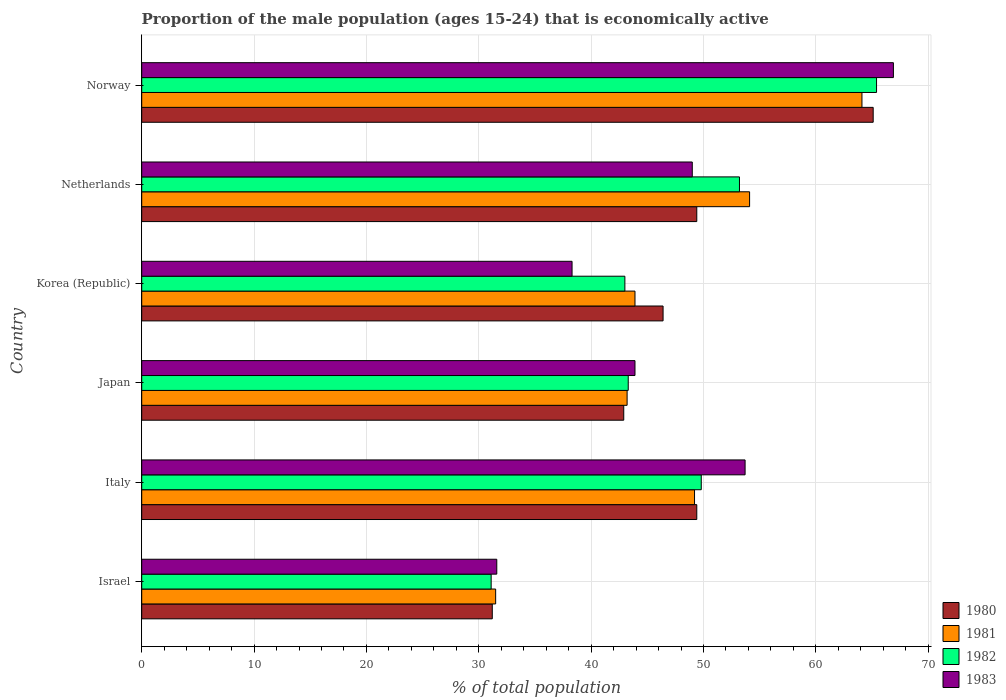How many groups of bars are there?
Your response must be concise. 6. Are the number of bars per tick equal to the number of legend labels?
Give a very brief answer. Yes. How many bars are there on the 5th tick from the top?
Your response must be concise. 4. How many bars are there on the 4th tick from the bottom?
Offer a very short reply. 4. What is the proportion of the male population that is economically active in 1982 in Netherlands?
Ensure brevity in your answer.  53.2. Across all countries, what is the maximum proportion of the male population that is economically active in 1980?
Provide a short and direct response. 65.1. Across all countries, what is the minimum proportion of the male population that is economically active in 1981?
Offer a terse response. 31.5. In which country was the proportion of the male population that is economically active in 1981 maximum?
Provide a short and direct response. Norway. What is the total proportion of the male population that is economically active in 1983 in the graph?
Give a very brief answer. 283.4. What is the difference between the proportion of the male population that is economically active in 1982 in Israel and that in Korea (Republic)?
Give a very brief answer. -11.9. What is the difference between the proportion of the male population that is economically active in 1981 in Japan and the proportion of the male population that is economically active in 1982 in Italy?
Offer a terse response. -6.6. What is the average proportion of the male population that is economically active in 1983 per country?
Give a very brief answer. 47.23. What is the difference between the proportion of the male population that is economically active in 1980 and proportion of the male population that is economically active in 1983 in Japan?
Your answer should be very brief. -1. In how many countries, is the proportion of the male population that is economically active in 1981 greater than 44 %?
Offer a terse response. 3. What is the ratio of the proportion of the male population that is economically active in 1981 in Italy to that in Norway?
Give a very brief answer. 0.77. Is the proportion of the male population that is economically active in 1982 in Japan less than that in Norway?
Provide a succinct answer. Yes. What is the difference between the highest and the second highest proportion of the male population that is economically active in 1981?
Your answer should be very brief. 10. What is the difference between the highest and the lowest proportion of the male population that is economically active in 1982?
Make the answer very short. 34.3. Is it the case that in every country, the sum of the proportion of the male population that is economically active in 1980 and proportion of the male population that is economically active in 1982 is greater than the proportion of the male population that is economically active in 1983?
Provide a short and direct response. Yes. How many countries are there in the graph?
Your answer should be compact. 6. Does the graph contain grids?
Provide a succinct answer. Yes. How many legend labels are there?
Keep it short and to the point. 4. How are the legend labels stacked?
Your answer should be compact. Vertical. What is the title of the graph?
Make the answer very short. Proportion of the male population (ages 15-24) that is economically active. What is the label or title of the X-axis?
Provide a short and direct response. % of total population. What is the % of total population of 1980 in Israel?
Offer a very short reply. 31.2. What is the % of total population in 1981 in Israel?
Provide a succinct answer. 31.5. What is the % of total population in 1982 in Israel?
Keep it short and to the point. 31.1. What is the % of total population in 1983 in Israel?
Keep it short and to the point. 31.6. What is the % of total population of 1980 in Italy?
Provide a succinct answer. 49.4. What is the % of total population in 1981 in Italy?
Your answer should be compact. 49.2. What is the % of total population in 1982 in Italy?
Your answer should be very brief. 49.8. What is the % of total population of 1983 in Italy?
Provide a short and direct response. 53.7. What is the % of total population in 1980 in Japan?
Your answer should be very brief. 42.9. What is the % of total population in 1981 in Japan?
Provide a succinct answer. 43.2. What is the % of total population in 1982 in Japan?
Your answer should be very brief. 43.3. What is the % of total population in 1983 in Japan?
Keep it short and to the point. 43.9. What is the % of total population in 1980 in Korea (Republic)?
Offer a very short reply. 46.4. What is the % of total population in 1981 in Korea (Republic)?
Offer a very short reply. 43.9. What is the % of total population in 1983 in Korea (Republic)?
Make the answer very short. 38.3. What is the % of total population of 1980 in Netherlands?
Your answer should be very brief. 49.4. What is the % of total population in 1981 in Netherlands?
Give a very brief answer. 54.1. What is the % of total population in 1982 in Netherlands?
Give a very brief answer. 53.2. What is the % of total population in 1983 in Netherlands?
Keep it short and to the point. 49. What is the % of total population of 1980 in Norway?
Your response must be concise. 65.1. What is the % of total population in 1981 in Norway?
Give a very brief answer. 64.1. What is the % of total population in 1982 in Norway?
Your answer should be very brief. 65.4. What is the % of total population in 1983 in Norway?
Offer a very short reply. 66.9. Across all countries, what is the maximum % of total population of 1980?
Offer a terse response. 65.1. Across all countries, what is the maximum % of total population in 1981?
Ensure brevity in your answer.  64.1. Across all countries, what is the maximum % of total population of 1982?
Ensure brevity in your answer.  65.4. Across all countries, what is the maximum % of total population of 1983?
Make the answer very short. 66.9. Across all countries, what is the minimum % of total population in 1980?
Keep it short and to the point. 31.2. Across all countries, what is the minimum % of total population of 1981?
Your response must be concise. 31.5. Across all countries, what is the minimum % of total population of 1982?
Offer a terse response. 31.1. Across all countries, what is the minimum % of total population in 1983?
Provide a short and direct response. 31.6. What is the total % of total population of 1980 in the graph?
Your answer should be very brief. 284.4. What is the total % of total population in 1981 in the graph?
Your response must be concise. 286. What is the total % of total population of 1982 in the graph?
Your answer should be compact. 285.8. What is the total % of total population in 1983 in the graph?
Your response must be concise. 283.4. What is the difference between the % of total population in 1980 in Israel and that in Italy?
Offer a terse response. -18.2. What is the difference between the % of total population of 1981 in Israel and that in Italy?
Your response must be concise. -17.7. What is the difference between the % of total population in 1982 in Israel and that in Italy?
Your answer should be very brief. -18.7. What is the difference between the % of total population of 1983 in Israel and that in Italy?
Your response must be concise. -22.1. What is the difference between the % of total population of 1981 in Israel and that in Japan?
Offer a terse response. -11.7. What is the difference between the % of total population in 1983 in Israel and that in Japan?
Give a very brief answer. -12.3. What is the difference between the % of total population in 1980 in Israel and that in Korea (Republic)?
Your response must be concise. -15.2. What is the difference between the % of total population of 1981 in Israel and that in Korea (Republic)?
Your response must be concise. -12.4. What is the difference between the % of total population in 1982 in Israel and that in Korea (Republic)?
Your answer should be very brief. -11.9. What is the difference between the % of total population of 1983 in Israel and that in Korea (Republic)?
Ensure brevity in your answer.  -6.7. What is the difference between the % of total population in 1980 in Israel and that in Netherlands?
Offer a terse response. -18.2. What is the difference between the % of total population in 1981 in Israel and that in Netherlands?
Provide a short and direct response. -22.6. What is the difference between the % of total population of 1982 in Israel and that in Netherlands?
Offer a very short reply. -22.1. What is the difference between the % of total population of 1983 in Israel and that in Netherlands?
Ensure brevity in your answer.  -17.4. What is the difference between the % of total population in 1980 in Israel and that in Norway?
Offer a terse response. -33.9. What is the difference between the % of total population in 1981 in Israel and that in Norway?
Ensure brevity in your answer.  -32.6. What is the difference between the % of total population in 1982 in Israel and that in Norway?
Offer a terse response. -34.3. What is the difference between the % of total population of 1983 in Israel and that in Norway?
Give a very brief answer. -35.3. What is the difference between the % of total population of 1982 in Italy and that in Japan?
Give a very brief answer. 6.5. What is the difference between the % of total population of 1983 in Italy and that in Japan?
Keep it short and to the point. 9.8. What is the difference between the % of total population in 1981 in Italy and that in Korea (Republic)?
Your response must be concise. 5.3. What is the difference between the % of total population in 1980 in Italy and that in Netherlands?
Your answer should be compact. 0. What is the difference between the % of total population in 1982 in Italy and that in Netherlands?
Give a very brief answer. -3.4. What is the difference between the % of total population in 1980 in Italy and that in Norway?
Provide a succinct answer. -15.7. What is the difference between the % of total population in 1981 in Italy and that in Norway?
Give a very brief answer. -14.9. What is the difference between the % of total population in 1982 in Italy and that in Norway?
Offer a very short reply. -15.6. What is the difference between the % of total population in 1981 in Japan and that in Korea (Republic)?
Your answer should be compact. -0.7. What is the difference between the % of total population in 1982 in Japan and that in Korea (Republic)?
Offer a very short reply. 0.3. What is the difference between the % of total population in 1980 in Japan and that in Netherlands?
Provide a succinct answer. -6.5. What is the difference between the % of total population of 1982 in Japan and that in Netherlands?
Offer a very short reply. -9.9. What is the difference between the % of total population in 1983 in Japan and that in Netherlands?
Make the answer very short. -5.1. What is the difference between the % of total population in 1980 in Japan and that in Norway?
Provide a short and direct response. -22.2. What is the difference between the % of total population in 1981 in Japan and that in Norway?
Make the answer very short. -20.9. What is the difference between the % of total population in 1982 in Japan and that in Norway?
Give a very brief answer. -22.1. What is the difference between the % of total population in 1983 in Japan and that in Norway?
Keep it short and to the point. -23. What is the difference between the % of total population of 1980 in Korea (Republic) and that in Netherlands?
Keep it short and to the point. -3. What is the difference between the % of total population in 1982 in Korea (Republic) and that in Netherlands?
Provide a short and direct response. -10.2. What is the difference between the % of total population of 1983 in Korea (Republic) and that in Netherlands?
Offer a very short reply. -10.7. What is the difference between the % of total population in 1980 in Korea (Republic) and that in Norway?
Offer a very short reply. -18.7. What is the difference between the % of total population in 1981 in Korea (Republic) and that in Norway?
Offer a terse response. -20.2. What is the difference between the % of total population in 1982 in Korea (Republic) and that in Norway?
Offer a very short reply. -22.4. What is the difference between the % of total population of 1983 in Korea (Republic) and that in Norway?
Your answer should be very brief. -28.6. What is the difference between the % of total population of 1980 in Netherlands and that in Norway?
Provide a short and direct response. -15.7. What is the difference between the % of total population of 1981 in Netherlands and that in Norway?
Your answer should be very brief. -10. What is the difference between the % of total population in 1982 in Netherlands and that in Norway?
Keep it short and to the point. -12.2. What is the difference between the % of total population in 1983 in Netherlands and that in Norway?
Your answer should be very brief. -17.9. What is the difference between the % of total population of 1980 in Israel and the % of total population of 1982 in Italy?
Provide a short and direct response. -18.6. What is the difference between the % of total population in 1980 in Israel and the % of total population in 1983 in Italy?
Your response must be concise. -22.5. What is the difference between the % of total population in 1981 in Israel and the % of total population in 1982 in Italy?
Offer a very short reply. -18.3. What is the difference between the % of total population of 1981 in Israel and the % of total population of 1983 in Italy?
Your answer should be very brief. -22.2. What is the difference between the % of total population of 1982 in Israel and the % of total population of 1983 in Italy?
Offer a very short reply. -22.6. What is the difference between the % of total population in 1980 in Israel and the % of total population in 1981 in Japan?
Ensure brevity in your answer.  -12. What is the difference between the % of total population of 1980 in Israel and the % of total population of 1982 in Japan?
Provide a succinct answer. -12.1. What is the difference between the % of total population of 1981 in Israel and the % of total population of 1982 in Japan?
Offer a very short reply. -11.8. What is the difference between the % of total population of 1981 in Israel and the % of total population of 1983 in Japan?
Keep it short and to the point. -12.4. What is the difference between the % of total population of 1981 in Israel and the % of total population of 1982 in Korea (Republic)?
Offer a very short reply. -11.5. What is the difference between the % of total population of 1980 in Israel and the % of total population of 1981 in Netherlands?
Offer a terse response. -22.9. What is the difference between the % of total population in 1980 in Israel and the % of total population in 1982 in Netherlands?
Your answer should be very brief. -22. What is the difference between the % of total population of 1980 in Israel and the % of total population of 1983 in Netherlands?
Give a very brief answer. -17.8. What is the difference between the % of total population in 1981 in Israel and the % of total population in 1982 in Netherlands?
Offer a very short reply. -21.7. What is the difference between the % of total population of 1981 in Israel and the % of total population of 1983 in Netherlands?
Give a very brief answer. -17.5. What is the difference between the % of total population in 1982 in Israel and the % of total population in 1983 in Netherlands?
Provide a short and direct response. -17.9. What is the difference between the % of total population in 1980 in Israel and the % of total population in 1981 in Norway?
Provide a short and direct response. -32.9. What is the difference between the % of total population in 1980 in Israel and the % of total population in 1982 in Norway?
Give a very brief answer. -34.2. What is the difference between the % of total population of 1980 in Israel and the % of total population of 1983 in Norway?
Give a very brief answer. -35.7. What is the difference between the % of total population in 1981 in Israel and the % of total population in 1982 in Norway?
Your answer should be very brief. -33.9. What is the difference between the % of total population in 1981 in Israel and the % of total population in 1983 in Norway?
Your answer should be very brief. -35.4. What is the difference between the % of total population of 1982 in Israel and the % of total population of 1983 in Norway?
Offer a terse response. -35.8. What is the difference between the % of total population in 1980 in Italy and the % of total population in 1981 in Japan?
Offer a very short reply. 6.2. What is the difference between the % of total population in 1980 in Italy and the % of total population in 1982 in Japan?
Your answer should be very brief. 6.1. What is the difference between the % of total population of 1980 in Italy and the % of total population of 1983 in Japan?
Make the answer very short. 5.5. What is the difference between the % of total population of 1981 in Italy and the % of total population of 1982 in Japan?
Provide a succinct answer. 5.9. What is the difference between the % of total population in 1981 in Italy and the % of total population in 1983 in Japan?
Give a very brief answer. 5.3. What is the difference between the % of total population of 1980 in Italy and the % of total population of 1982 in Korea (Republic)?
Ensure brevity in your answer.  6.4. What is the difference between the % of total population in 1980 in Italy and the % of total population in 1983 in Korea (Republic)?
Ensure brevity in your answer.  11.1. What is the difference between the % of total population in 1981 in Italy and the % of total population in 1982 in Korea (Republic)?
Ensure brevity in your answer.  6.2. What is the difference between the % of total population of 1982 in Italy and the % of total population of 1983 in Korea (Republic)?
Keep it short and to the point. 11.5. What is the difference between the % of total population of 1980 in Italy and the % of total population of 1981 in Netherlands?
Offer a very short reply. -4.7. What is the difference between the % of total population in 1980 in Italy and the % of total population in 1982 in Netherlands?
Provide a succinct answer. -3.8. What is the difference between the % of total population in 1981 in Italy and the % of total population in 1982 in Netherlands?
Provide a succinct answer. -4. What is the difference between the % of total population of 1981 in Italy and the % of total population of 1983 in Netherlands?
Your answer should be compact. 0.2. What is the difference between the % of total population in 1980 in Italy and the % of total population in 1981 in Norway?
Your response must be concise. -14.7. What is the difference between the % of total population in 1980 in Italy and the % of total population in 1982 in Norway?
Ensure brevity in your answer.  -16. What is the difference between the % of total population of 1980 in Italy and the % of total population of 1983 in Norway?
Offer a very short reply. -17.5. What is the difference between the % of total population of 1981 in Italy and the % of total population of 1982 in Norway?
Provide a short and direct response. -16.2. What is the difference between the % of total population of 1981 in Italy and the % of total population of 1983 in Norway?
Your answer should be compact. -17.7. What is the difference between the % of total population in 1982 in Italy and the % of total population in 1983 in Norway?
Keep it short and to the point. -17.1. What is the difference between the % of total population in 1980 in Japan and the % of total population in 1982 in Korea (Republic)?
Your answer should be very brief. -0.1. What is the difference between the % of total population in 1980 in Japan and the % of total population in 1981 in Netherlands?
Keep it short and to the point. -11.2. What is the difference between the % of total population in 1980 in Japan and the % of total population in 1983 in Netherlands?
Your answer should be very brief. -6.1. What is the difference between the % of total population of 1981 in Japan and the % of total population of 1982 in Netherlands?
Give a very brief answer. -10. What is the difference between the % of total population of 1982 in Japan and the % of total population of 1983 in Netherlands?
Offer a terse response. -5.7. What is the difference between the % of total population in 1980 in Japan and the % of total population in 1981 in Norway?
Keep it short and to the point. -21.2. What is the difference between the % of total population in 1980 in Japan and the % of total population in 1982 in Norway?
Your answer should be compact. -22.5. What is the difference between the % of total population of 1981 in Japan and the % of total population of 1982 in Norway?
Give a very brief answer. -22.2. What is the difference between the % of total population in 1981 in Japan and the % of total population in 1983 in Norway?
Provide a short and direct response. -23.7. What is the difference between the % of total population in 1982 in Japan and the % of total population in 1983 in Norway?
Your answer should be compact. -23.6. What is the difference between the % of total population of 1980 in Korea (Republic) and the % of total population of 1981 in Netherlands?
Your answer should be very brief. -7.7. What is the difference between the % of total population in 1980 in Korea (Republic) and the % of total population in 1983 in Netherlands?
Offer a terse response. -2.6. What is the difference between the % of total population in 1981 in Korea (Republic) and the % of total population in 1982 in Netherlands?
Give a very brief answer. -9.3. What is the difference between the % of total population of 1981 in Korea (Republic) and the % of total population of 1983 in Netherlands?
Offer a very short reply. -5.1. What is the difference between the % of total population in 1980 in Korea (Republic) and the % of total population in 1981 in Norway?
Offer a very short reply. -17.7. What is the difference between the % of total population of 1980 in Korea (Republic) and the % of total population of 1982 in Norway?
Keep it short and to the point. -19. What is the difference between the % of total population of 1980 in Korea (Republic) and the % of total population of 1983 in Norway?
Your response must be concise. -20.5. What is the difference between the % of total population of 1981 in Korea (Republic) and the % of total population of 1982 in Norway?
Offer a very short reply. -21.5. What is the difference between the % of total population in 1981 in Korea (Republic) and the % of total population in 1983 in Norway?
Your answer should be compact. -23. What is the difference between the % of total population in 1982 in Korea (Republic) and the % of total population in 1983 in Norway?
Keep it short and to the point. -23.9. What is the difference between the % of total population of 1980 in Netherlands and the % of total population of 1981 in Norway?
Ensure brevity in your answer.  -14.7. What is the difference between the % of total population in 1980 in Netherlands and the % of total population in 1983 in Norway?
Your answer should be very brief. -17.5. What is the difference between the % of total population of 1981 in Netherlands and the % of total population of 1983 in Norway?
Your answer should be very brief. -12.8. What is the difference between the % of total population of 1982 in Netherlands and the % of total population of 1983 in Norway?
Offer a very short reply. -13.7. What is the average % of total population of 1980 per country?
Your response must be concise. 47.4. What is the average % of total population of 1981 per country?
Your response must be concise. 47.67. What is the average % of total population in 1982 per country?
Provide a short and direct response. 47.63. What is the average % of total population of 1983 per country?
Give a very brief answer. 47.23. What is the difference between the % of total population of 1980 and % of total population of 1983 in Israel?
Provide a short and direct response. -0.4. What is the difference between the % of total population in 1981 and % of total population in 1983 in Israel?
Offer a terse response. -0.1. What is the difference between the % of total population in 1982 and % of total population in 1983 in Israel?
Offer a terse response. -0.5. What is the difference between the % of total population in 1980 and % of total population in 1981 in Italy?
Provide a succinct answer. 0.2. What is the difference between the % of total population in 1980 and % of total population in 1982 in Italy?
Offer a very short reply. -0.4. What is the difference between the % of total population of 1981 and % of total population of 1982 in Italy?
Keep it short and to the point. -0.6. What is the difference between the % of total population of 1980 and % of total population of 1981 in Japan?
Make the answer very short. -0.3. What is the difference between the % of total population in 1980 and % of total population in 1982 in Japan?
Make the answer very short. -0.4. What is the difference between the % of total population in 1980 and % of total population in 1983 in Japan?
Make the answer very short. -1. What is the difference between the % of total population in 1981 and % of total population in 1982 in Japan?
Your answer should be compact. -0.1. What is the difference between the % of total population in 1981 and % of total population in 1983 in Japan?
Make the answer very short. -0.7. What is the difference between the % of total population of 1980 and % of total population of 1983 in Korea (Republic)?
Ensure brevity in your answer.  8.1. What is the difference between the % of total population in 1982 and % of total population in 1983 in Korea (Republic)?
Give a very brief answer. 4.7. What is the difference between the % of total population in 1980 and % of total population in 1982 in Netherlands?
Provide a short and direct response. -3.8. What is the difference between the % of total population in 1980 and % of total population in 1983 in Netherlands?
Give a very brief answer. 0.4. What is the difference between the % of total population of 1981 and % of total population of 1982 in Netherlands?
Make the answer very short. 0.9. What is the difference between the % of total population of 1981 and % of total population of 1983 in Netherlands?
Give a very brief answer. 5.1. What is the difference between the % of total population in 1982 and % of total population in 1983 in Netherlands?
Make the answer very short. 4.2. What is the difference between the % of total population of 1980 and % of total population of 1982 in Norway?
Your response must be concise. -0.3. What is the difference between the % of total population of 1980 and % of total population of 1983 in Norway?
Offer a terse response. -1.8. What is the difference between the % of total population in 1981 and % of total population in 1982 in Norway?
Ensure brevity in your answer.  -1.3. What is the difference between the % of total population of 1982 and % of total population of 1983 in Norway?
Your answer should be very brief. -1.5. What is the ratio of the % of total population of 1980 in Israel to that in Italy?
Offer a very short reply. 0.63. What is the ratio of the % of total population of 1981 in Israel to that in Italy?
Give a very brief answer. 0.64. What is the ratio of the % of total population in 1982 in Israel to that in Italy?
Make the answer very short. 0.62. What is the ratio of the % of total population of 1983 in Israel to that in Italy?
Your answer should be compact. 0.59. What is the ratio of the % of total population of 1980 in Israel to that in Japan?
Make the answer very short. 0.73. What is the ratio of the % of total population of 1981 in Israel to that in Japan?
Provide a short and direct response. 0.73. What is the ratio of the % of total population in 1982 in Israel to that in Japan?
Make the answer very short. 0.72. What is the ratio of the % of total population in 1983 in Israel to that in Japan?
Give a very brief answer. 0.72. What is the ratio of the % of total population in 1980 in Israel to that in Korea (Republic)?
Offer a terse response. 0.67. What is the ratio of the % of total population of 1981 in Israel to that in Korea (Republic)?
Give a very brief answer. 0.72. What is the ratio of the % of total population of 1982 in Israel to that in Korea (Republic)?
Ensure brevity in your answer.  0.72. What is the ratio of the % of total population in 1983 in Israel to that in Korea (Republic)?
Your answer should be compact. 0.83. What is the ratio of the % of total population in 1980 in Israel to that in Netherlands?
Make the answer very short. 0.63. What is the ratio of the % of total population of 1981 in Israel to that in Netherlands?
Your answer should be very brief. 0.58. What is the ratio of the % of total population in 1982 in Israel to that in Netherlands?
Keep it short and to the point. 0.58. What is the ratio of the % of total population in 1983 in Israel to that in Netherlands?
Ensure brevity in your answer.  0.64. What is the ratio of the % of total population in 1980 in Israel to that in Norway?
Give a very brief answer. 0.48. What is the ratio of the % of total population in 1981 in Israel to that in Norway?
Your answer should be compact. 0.49. What is the ratio of the % of total population of 1982 in Israel to that in Norway?
Offer a terse response. 0.48. What is the ratio of the % of total population of 1983 in Israel to that in Norway?
Keep it short and to the point. 0.47. What is the ratio of the % of total population in 1980 in Italy to that in Japan?
Provide a short and direct response. 1.15. What is the ratio of the % of total population of 1981 in Italy to that in Japan?
Your response must be concise. 1.14. What is the ratio of the % of total population in 1982 in Italy to that in Japan?
Make the answer very short. 1.15. What is the ratio of the % of total population of 1983 in Italy to that in Japan?
Keep it short and to the point. 1.22. What is the ratio of the % of total population of 1980 in Italy to that in Korea (Republic)?
Offer a terse response. 1.06. What is the ratio of the % of total population in 1981 in Italy to that in Korea (Republic)?
Ensure brevity in your answer.  1.12. What is the ratio of the % of total population of 1982 in Italy to that in Korea (Republic)?
Ensure brevity in your answer.  1.16. What is the ratio of the % of total population in 1983 in Italy to that in Korea (Republic)?
Your answer should be very brief. 1.4. What is the ratio of the % of total population in 1981 in Italy to that in Netherlands?
Your answer should be very brief. 0.91. What is the ratio of the % of total population in 1982 in Italy to that in Netherlands?
Offer a very short reply. 0.94. What is the ratio of the % of total population of 1983 in Italy to that in Netherlands?
Ensure brevity in your answer.  1.1. What is the ratio of the % of total population in 1980 in Italy to that in Norway?
Give a very brief answer. 0.76. What is the ratio of the % of total population of 1981 in Italy to that in Norway?
Keep it short and to the point. 0.77. What is the ratio of the % of total population of 1982 in Italy to that in Norway?
Provide a short and direct response. 0.76. What is the ratio of the % of total population in 1983 in Italy to that in Norway?
Offer a terse response. 0.8. What is the ratio of the % of total population of 1980 in Japan to that in Korea (Republic)?
Provide a succinct answer. 0.92. What is the ratio of the % of total population of 1981 in Japan to that in Korea (Republic)?
Make the answer very short. 0.98. What is the ratio of the % of total population of 1982 in Japan to that in Korea (Republic)?
Your answer should be compact. 1.01. What is the ratio of the % of total population of 1983 in Japan to that in Korea (Republic)?
Keep it short and to the point. 1.15. What is the ratio of the % of total population in 1980 in Japan to that in Netherlands?
Provide a succinct answer. 0.87. What is the ratio of the % of total population of 1981 in Japan to that in Netherlands?
Ensure brevity in your answer.  0.8. What is the ratio of the % of total population in 1982 in Japan to that in Netherlands?
Offer a terse response. 0.81. What is the ratio of the % of total population of 1983 in Japan to that in Netherlands?
Provide a short and direct response. 0.9. What is the ratio of the % of total population in 1980 in Japan to that in Norway?
Give a very brief answer. 0.66. What is the ratio of the % of total population in 1981 in Japan to that in Norway?
Provide a short and direct response. 0.67. What is the ratio of the % of total population in 1982 in Japan to that in Norway?
Give a very brief answer. 0.66. What is the ratio of the % of total population of 1983 in Japan to that in Norway?
Provide a succinct answer. 0.66. What is the ratio of the % of total population of 1980 in Korea (Republic) to that in Netherlands?
Offer a very short reply. 0.94. What is the ratio of the % of total population in 1981 in Korea (Republic) to that in Netherlands?
Keep it short and to the point. 0.81. What is the ratio of the % of total population in 1982 in Korea (Republic) to that in Netherlands?
Your response must be concise. 0.81. What is the ratio of the % of total population in 1983 in Korea (Republic) to that in Netherlands?
Give a very brief answer. 0.78. What is the ratio of the % of total population in 1980 in Korea (Republic) to that in Norway?
Ensure brevity in your answer.  0.71. What is the ratio of the % of total population in 1981 in Korea (Republic) to that in Norway?
Give a very brief answer. 0.68. What is the ratio of the % of total population in 1982 in Korea (Republic) to that in Norway?
Offer a terse response. 0.66. What is the ratio of the % of total population of 1983 in Korea (Republic) to that in Norway?
Provide a short and direct response. 0.57. What is the ratio of the % of total population in 1980 in Netherlands to that in Norway?
Your answer should be compact. 0.76. What is the ratio of the % of total population of 1981 in Netherlands to that in Norway?
Provide a succinct answer. 0.84. What is the ratio of the % of total population in 1982 in Netherlands to that in Norway?
Keep it short and to the point. 0.81. What is the ratio of the % of total population of 1983 in Netherlands to that in Norway?
Give a very brief answer. 0.73. What is the difference between the highest and the second highest % of total population in 1981?
Make the answer very short. 10. What is the difference between the highest and the lowest % of total population in 1980?
Offer a terse response. 33.9. What is the difference between the highest and the lowest % of total population in 1981?
Provide a short and direct response. 32.6. What is the difference between the highest and the lowest % of total population of 1982?
Ensure brevity in your answer.  34.3. What is the difference between the highest and the lowest % of total population in 1983?
Provide a succinct answer. 35.3. 